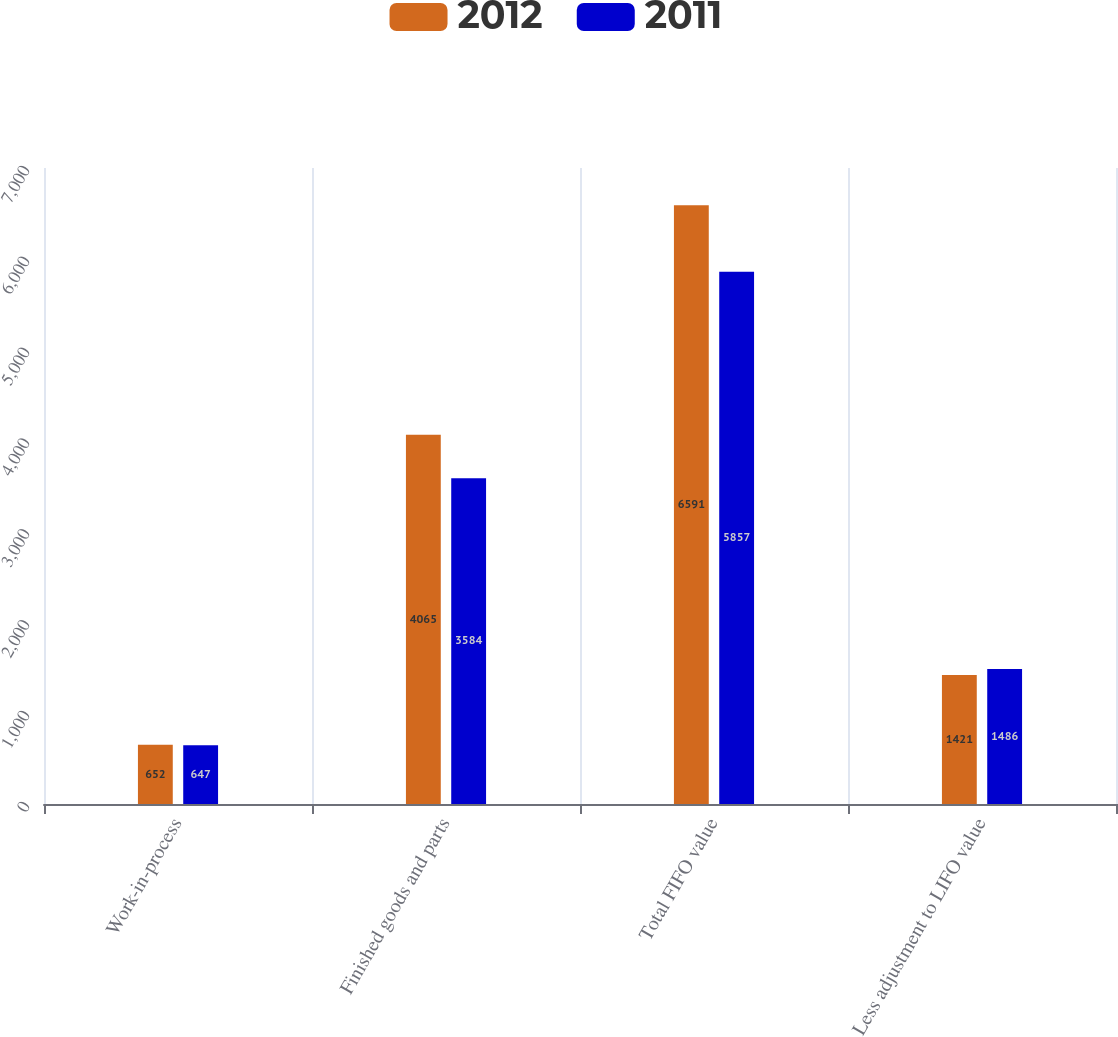Convert chart to OTSL. <chart><loc_0><loc_0><loc_500><loc_500><stacked_bar_chart><ecel><fcel>Work-in-process<fcel>Finished goods and parts<fcel>Total FIFO value<fcel>Less adjustment to LIFO value<nl><fcel>2012<fcel>652<fcel>4065<fcel>6591<fcel>1421<nl><fcel>2011<fcel>647<fcel>3584<fcel>5857<fcel>1486<nl></chart> 